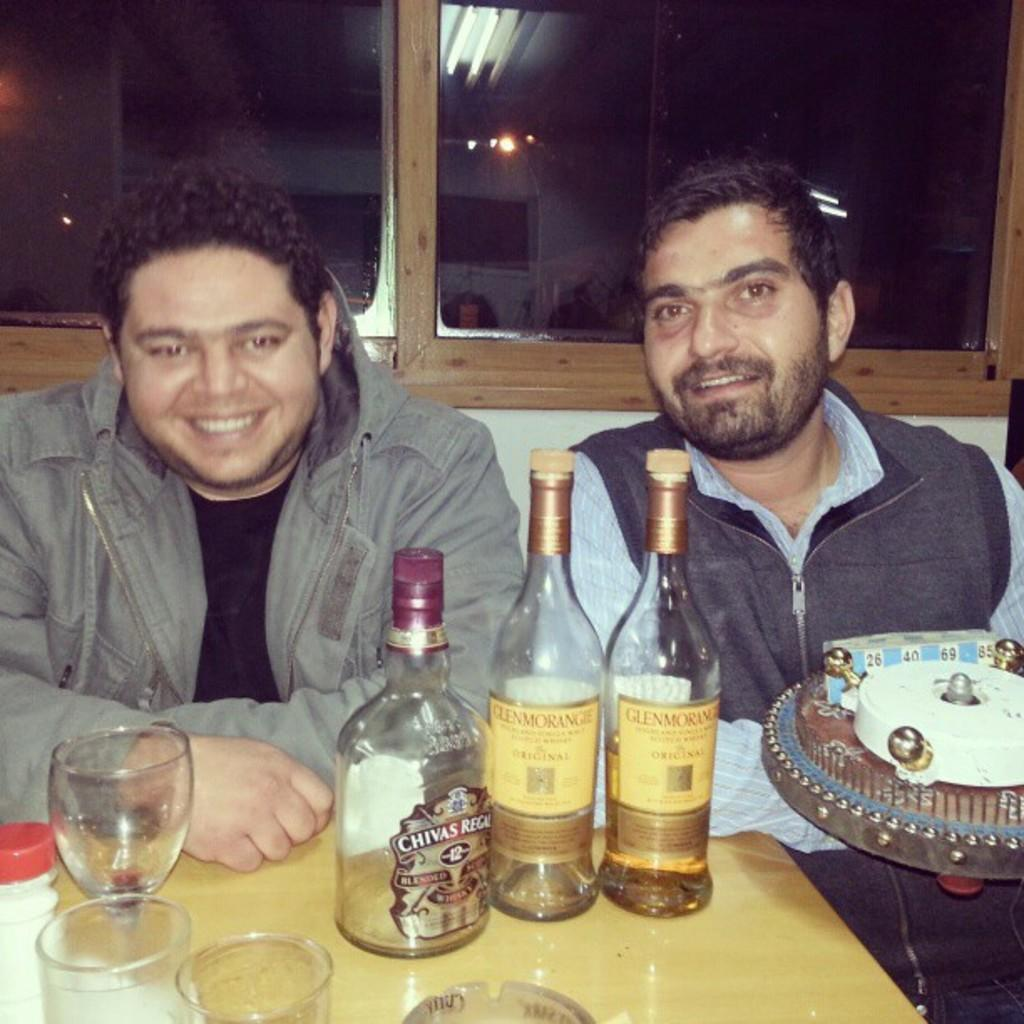How many people are in the image? There are two persons in the image. What are the persons doing in the image? The persons are sitting and smiling. What objects can be seen on the table in the image? There are bottles and glasses on the table. What is the man holding in the image? The man is holding a toy. What type of window is present in the image? There is a glass window in the image. What can be observed on the glass window in the image? There is a reflection of lights on the glass window. What type of pie is being offered to the persons in the image? There is no pie present in the image, and no one is offering anything to the persons. 